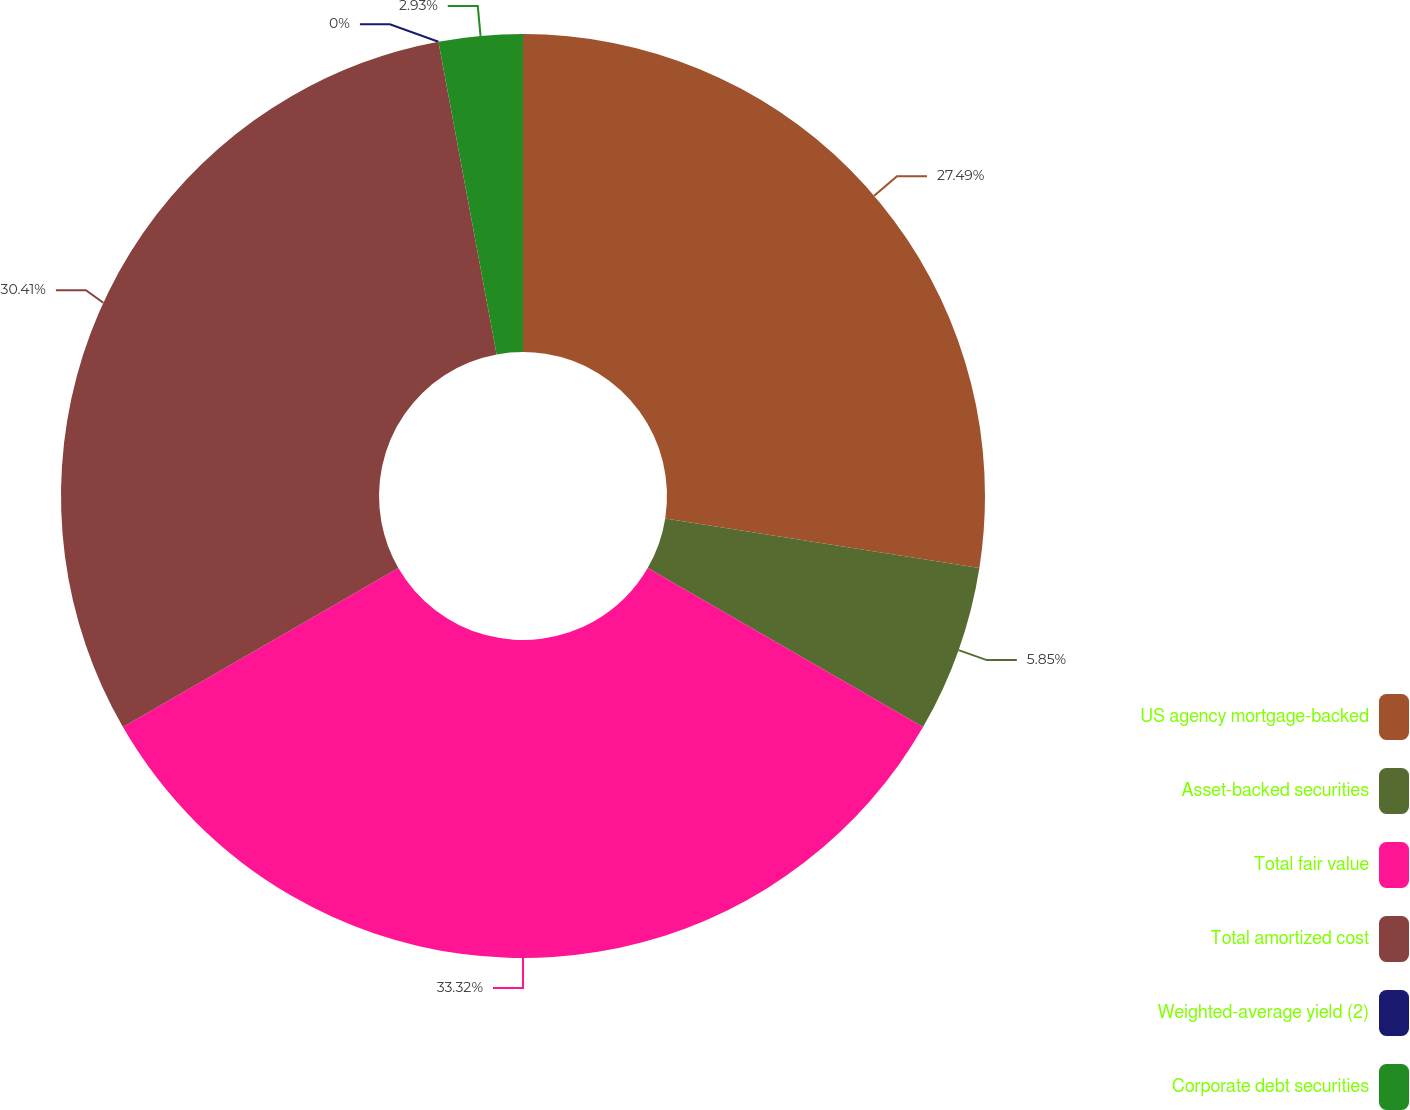<chart> <loc_0><loc_0><loc_500><loc_500><pie_chart><fcel>US agency mortgage-backed<fcel>Asset-backed securities<fcel>Total fair value<fcel>Total amortized cost<fcel>Weighted-average yield (2)<fcel>Corporate debt securities<nl><fcel>27.49%<fcel>5.85%<fcel>33.33%<fcel>30.41%<fcel>0.0%<fcel>2.93%<nl></chart> 